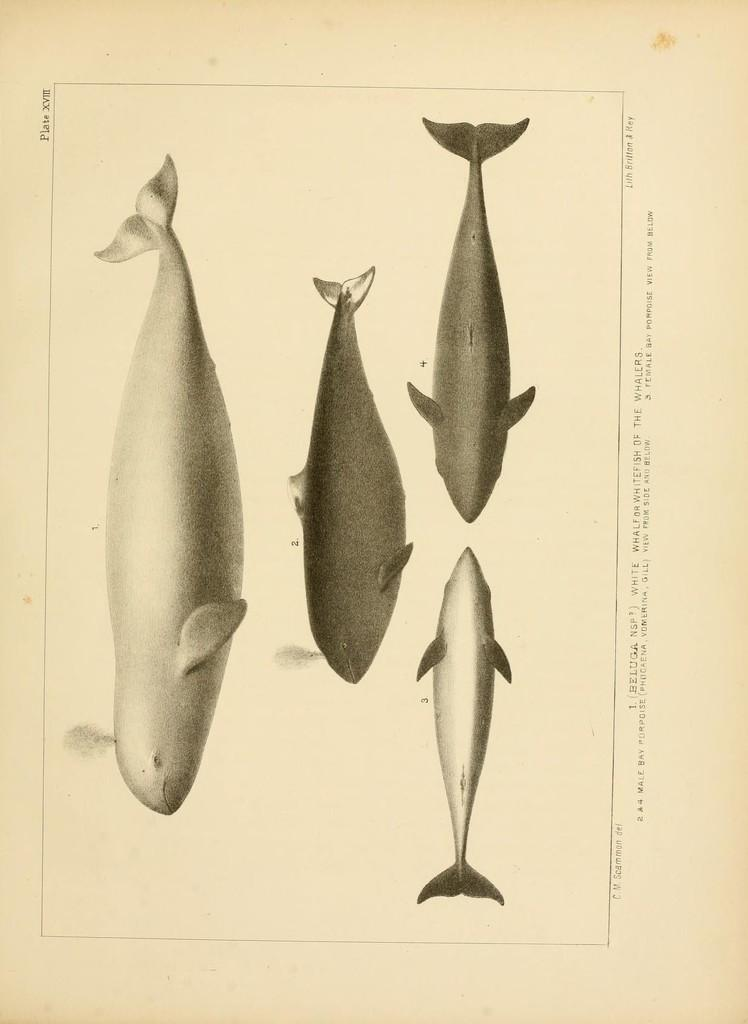What is the main subject of the paper in the image? The paper contains four diagrams of fishes. What else can be found on the paper besides the diagrams? There is text on the paper. Where is the text located on the paper? The text is located on the right side of the paper. What type of machine is depicted in the fiction story on the paper? There is no fiction story or machine depicted on the paper; it contains diagrams of fishes and text related to them. Can you describe the taste of the tongue in the image? There is no tongue present in the image; it features a paper with diagrams of fishes and text. 